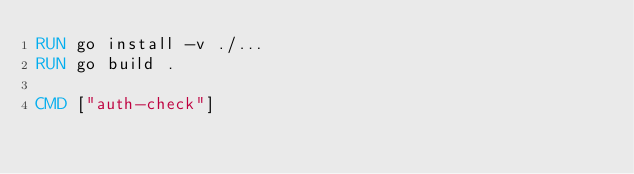Convert code to text. <code><loc_0><loc_0><loc_500><loc_500><_Dockerfile_>RUN go install -v ./...
RUN go build .

CMD ["auth-check"]</code> 